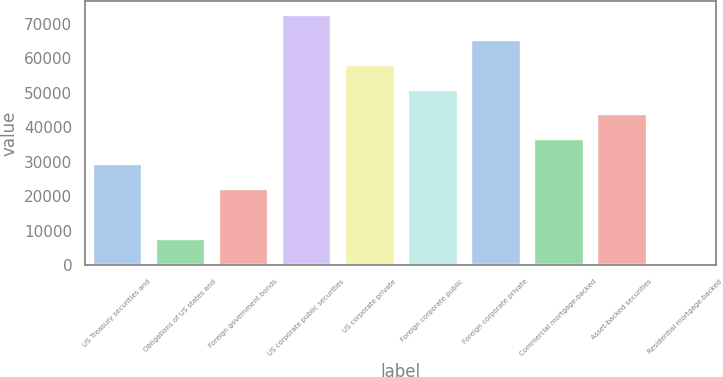<chart> <loc_0><loc_0><loc_500><loc_500><bar_chart><fcel>US Treasury securities and<fcel>Obligations of US states and<fcel>Foreign government bonds<fcel>US corporate public securities<fcel>US corporate private<fcel>Foreign corporate public<fcel>Foreign corporate private<fcel>Commercial mortgage-backed<fcel>Asset-backed securities<fcel>Residential mortgage-backed<nl><fcel>29566.2<fcel>7899.3<fcel>22343.9<fcel>72900<fcel>58455.4<fcel>51233.1<fcel>65677.7<fcel>36788.5<fcel>44010.8<fcel>677<nl></chart> 